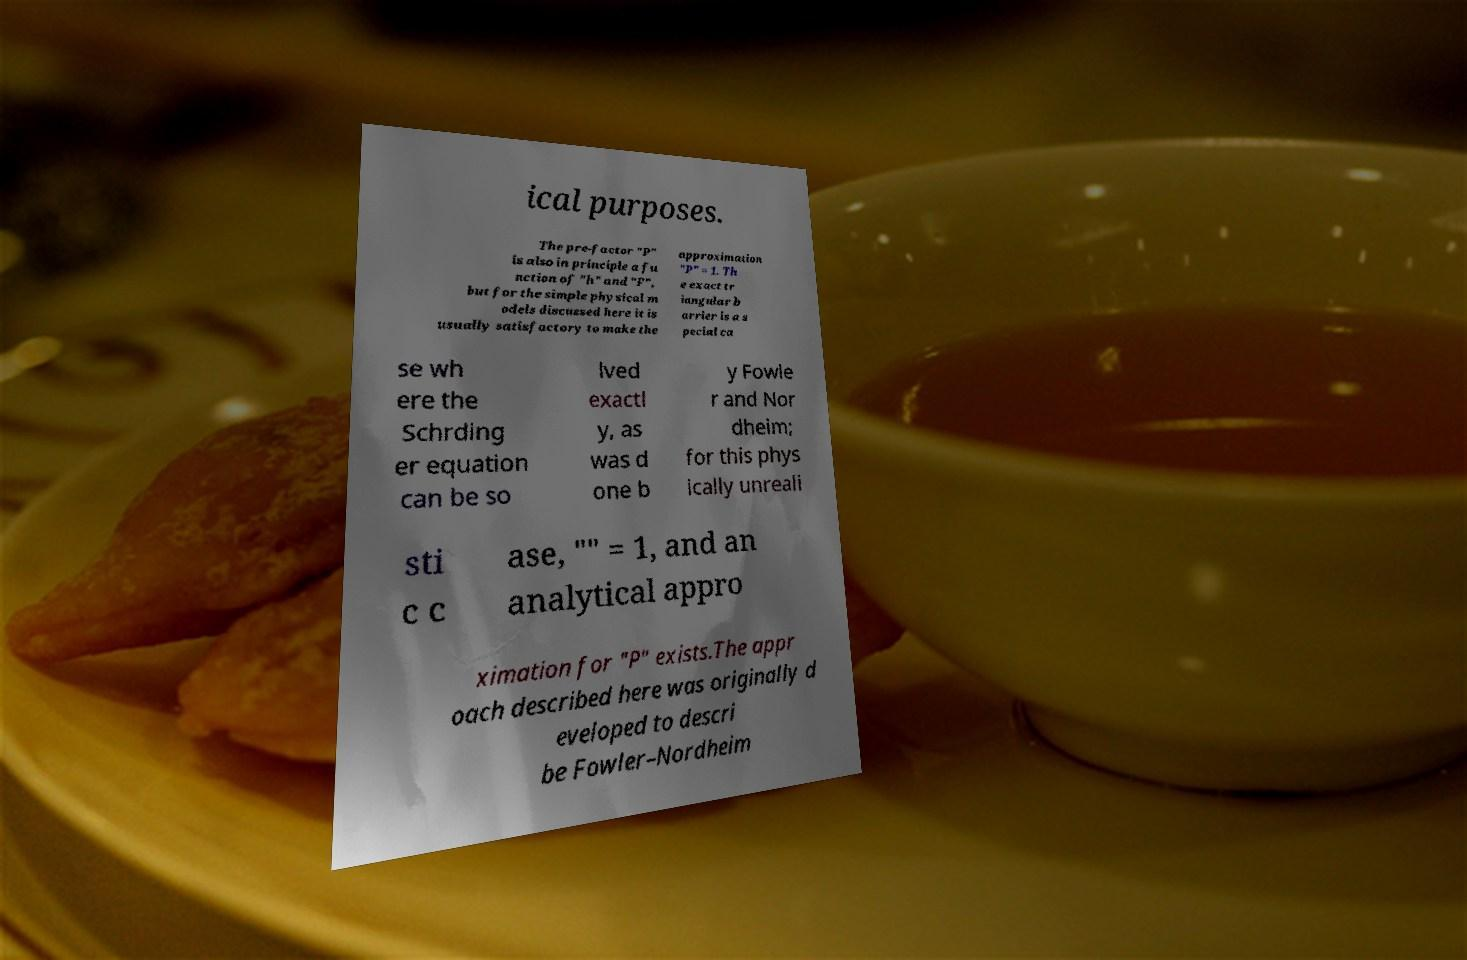Please identify and transcribe the text found in this image. ical purposes. The pre-factor "P" is also in principle a fu nction of "h" and "F", but for the simple physical m odels discussed here it is usually satisfactory to make the approximation "P" = 1. Th e exact tr iangular b arrier is a s pecial ca se wh ere the Schrding er equation can be so lved exactl y, as was d one b y Fowle r and Nor dheim; for this phys ically unreali sti c c ase, "" = 1, and an analytical appro ximation for "P" exists.The appr oach described here was originally d eveloped to descri be Fowler–Nordheim 